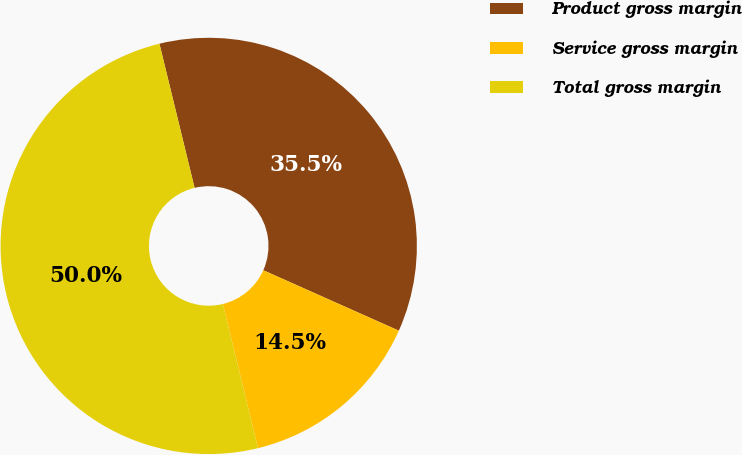<chart> <loc_0><loc_0><loc_500><loc_500><pie_chart><fcel>Product gross margin<fcel>Service gross margin<fcel>Total gross margin<nl><fcel>35.48%<fcel>14.52%<fcel>50.0%<nl></chart> 